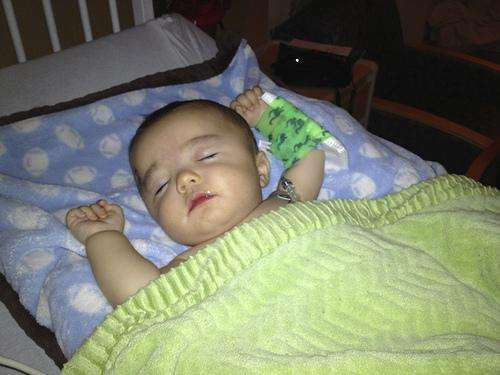What type of product advertisement could this image be used for? This image could be used for an advertisement promoting comfortable and stylish baby blankets or hospital equipment for infants. Describe the condition of the baby and what is covering them. The baby appears to be sleeping comfortably, covered with a light green blanket. Identify the primary object in the image and what is happening to it. The primary object in the image is a sleeping baby who is covered with a light green blanket. Mention a few objects that are located near the bed in the image. Next to the bed, there is a dark armchair and a wooden stand with drawers. Mention a distinctive feature about the blanket on the baby. The baby is covered with a light green blanket. List the objects on the end table. There is a black bag placed on the end table. What is a possible implication of the presence of a cast on the baby's arm? The cast on the baby's arm might imply that the baby was injured or had a surgery requiring immobilization for proper healing. What pattern is on the baby's cast and where is it located? The baby's cast has a green camouflage pattern and is located on the arm. Describe the furniture in the image. The room includes a bed with a blue patterned headboard, a dark armchair, and a wooden stand with drawers. What color is the baby blanket and what pattern does it have? The baby blanket is light green. 